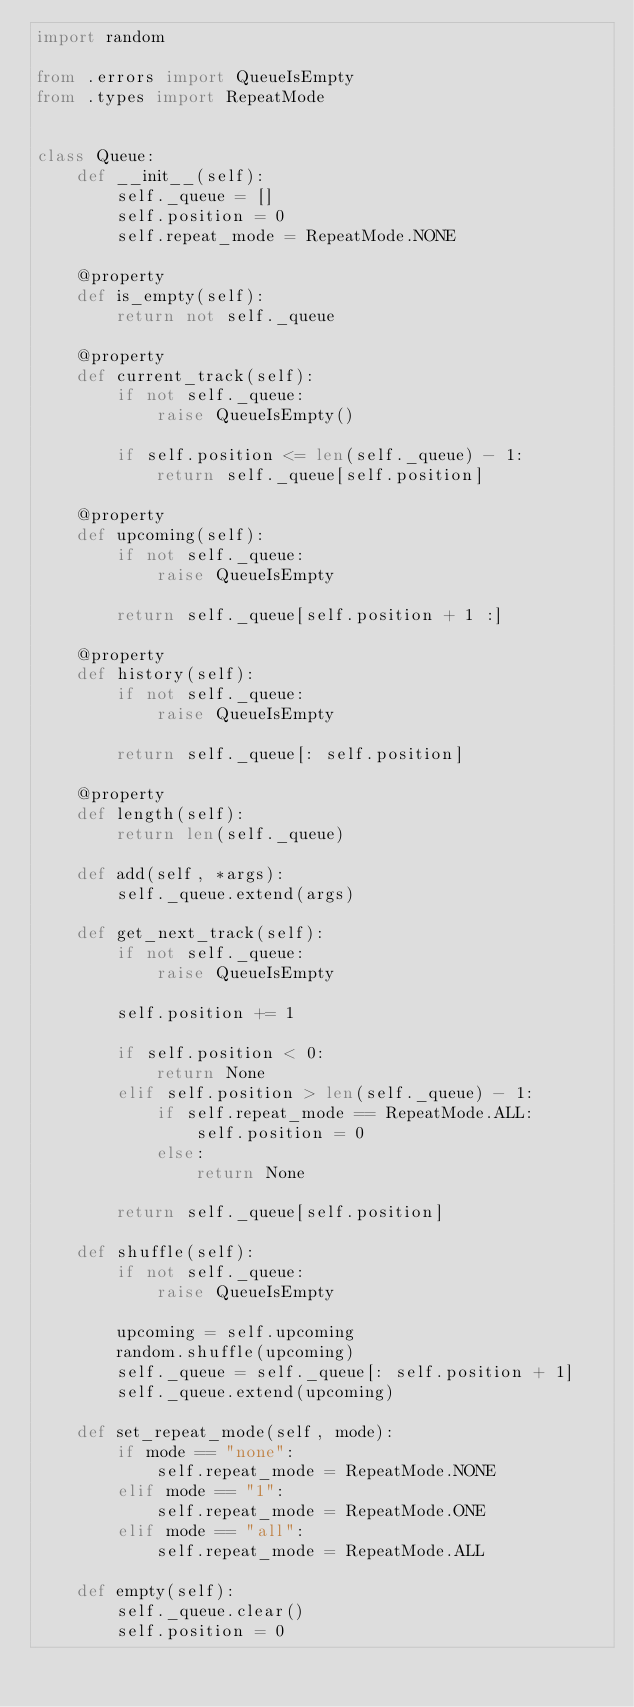Convert code to text. <code><loc_0><loc_0><loc_500><loc_500><_Python_>import random

from .errors import QueueIsEmpty
from .types import RepeatMode


class Queue:
    def __init__(self):
        self._queue = []
        self.position = 0
        self.repeat_mode = RepeatMode.NONE

    @property
    def is_empty(self):
        return not self._queue

    @property
    def current_track(self):
        if not self._queue:
            raise QueueIsEmpty()

        if self.position <= len(self._queue) - 1:
            return self._queue[self.position]

    @property
    def upcoming(self):
        if not self._queue:
            raise QueueIsEmpty

        return self._queue[self.position + 1 :]

    @property
    def history(self):
        if not self._queue:
            raise QueueIsEmpty

        return self._queue[: self.position]

    @property
    def length(self):
        return len(self._queue)

    def add(self, *args):
        self._queue.extend(args)

    def get_next_track(self):
        if not self._queue:
            raise QueueIsEmpty

        self.position += 1

        if self.position < 0:
            return None
        elif self.position > len(self._queue) - 1:
            if self.repeat_mode == RepeatMode.ALL:
                self.position = 0
            else:
                return None

        return self._queue[self.position]

    def shuffle(self):
        if not self._queue:
            raise QueueIsEmpty

        upcoming = self.upcoming
        random.shuffle(upcoming)
        self._queue = self._queue[: self.position + 1]
        self._queue.extend(upcoming)

    def set_repeat_mode(self, mode):
        if mode == "none":
            self.repeat_mode = RepeatMode.NONE
        elif mode == "1":
            self.repeat_mode = RepeatMode.ONE
        elif mode == "all":
            self.repeat_mode = RepeatMode.ALL

    def empty(self):
        self._queue.clear()
        self.position = 0
</code> 